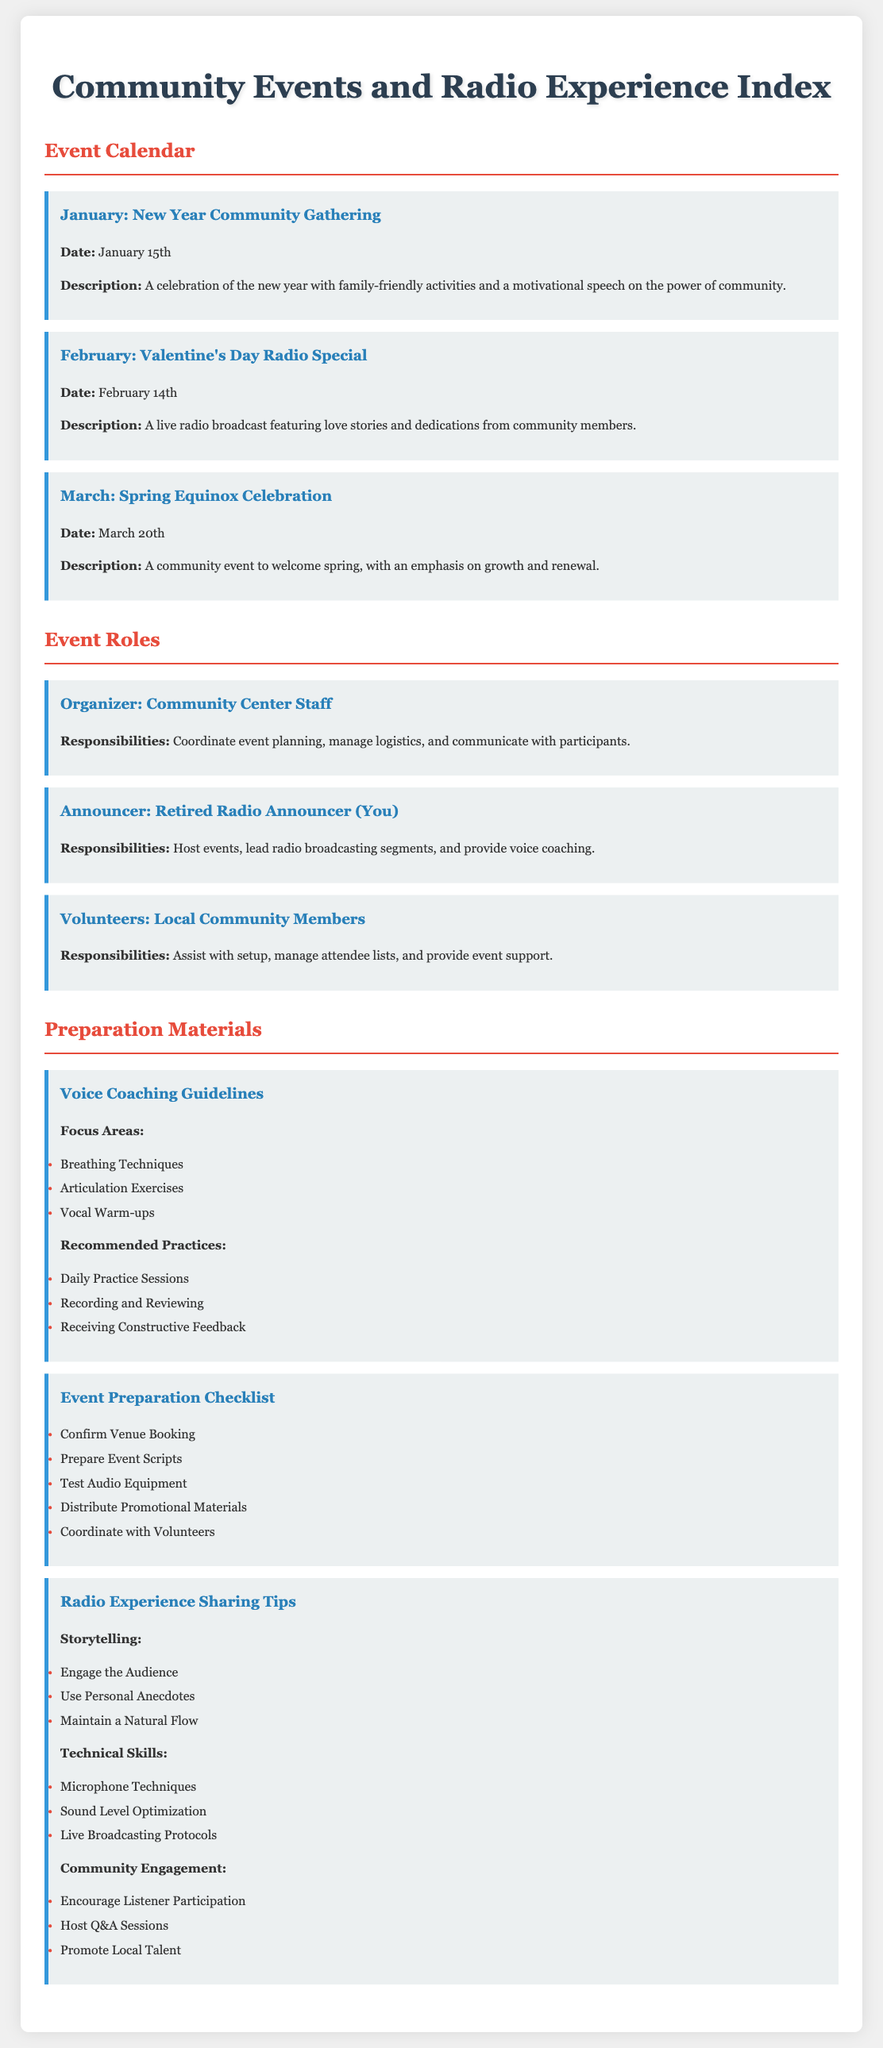What is the date of the New Year Community Gathering? The date of the event is explicitly mentioned in the document as January 15th.
Answer: January 15th Who is responsible for hosting events? The responsibilities of the retired radio announcer include hosting events, as specified under the Announcer role.
Answer: Retired Radio Announcer What is one focus area listed in the Voice Coaching Guidelines? The document includes several focus areas, one of which is outlined in the list, specifically Breathing Techniques.
Answer: Breathing Techniques Which month features the Valentine's Day Radio Special? The document clearly indicates that this special event is scheduled for February.
Answer: February What is one responsibility of volunteers? The document lists responsibilities of volunteers, including assisting with setup.
Answer: Assist with setup How many community events are listed in the calendar? The document provides details of three specific events as part of the event calendar.
Answer: Three What is one recommended practice for voice coaching? The document includes several recommended practices, one of which is Daily Practice Sessions.
Answer: Daily Practice Sessions What should be confirmed according to the Event Preparation Checklist? The checklist specifies that confirming the venue booking is a crucial preparation task.
Answer: Confirm Venue Booking Name one storytelling tip from the Radio Experience Sharing Tips. The document provides multiple tips, one being to Engage the Audience.
Answer: Engage the Audience 